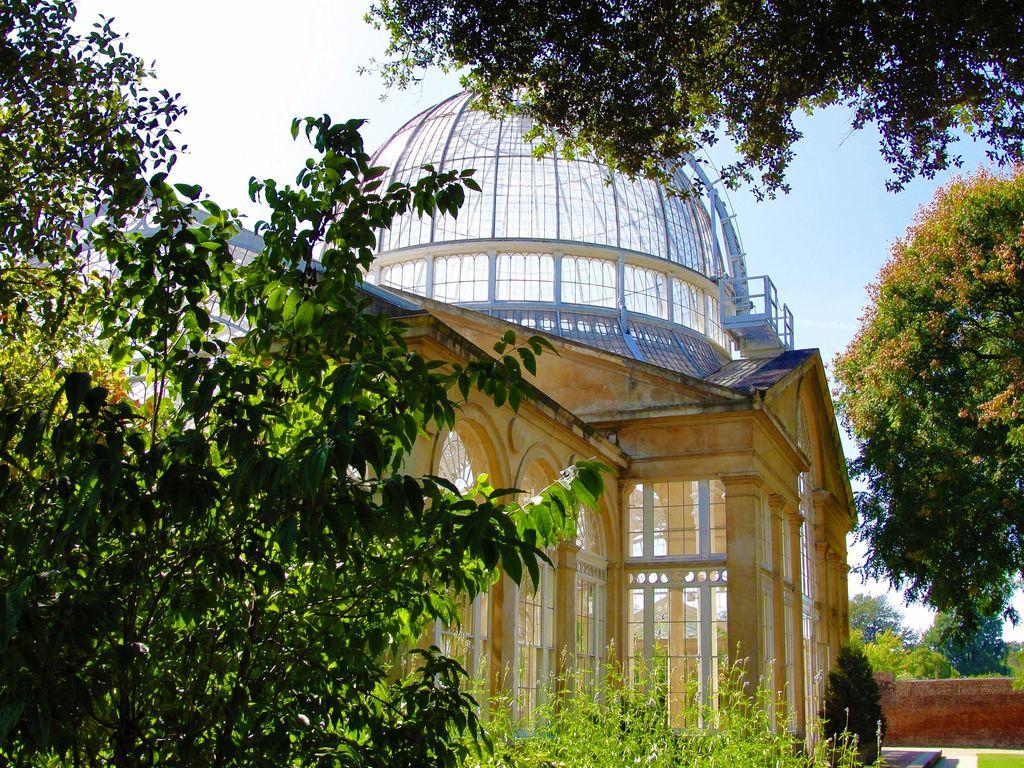What type of natural elements can be seen in the image? There are many trees in the image. What type of structure is present in the image? There is a building with walls, arches, glasses, and roofs in the image. Can you describe any additional architectural features in the image? There is a small wall in the image. What can be seen in the background of the image? The sky is visible in the background of the image. What type of cart can be seen in the image? There is no cart present in the image. What type of reaction can be seen in the image? There is no reaction depicted in the image; it is a still scene of trees, a building, and the sky. 